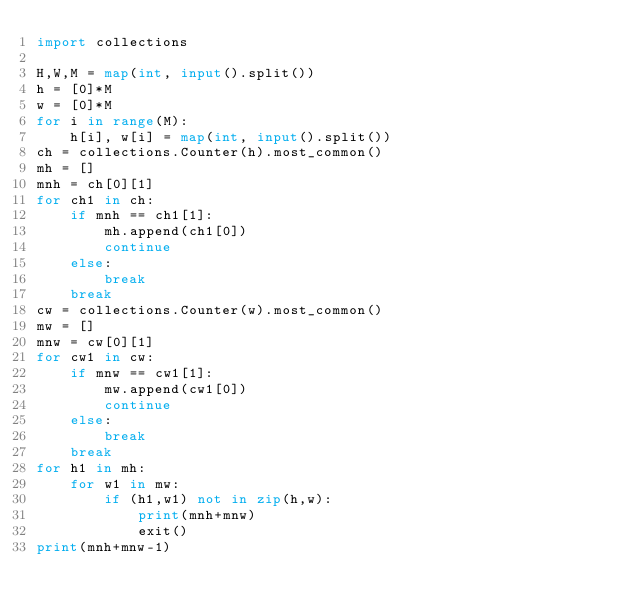Convert code to text. <code><loc_0><loc_0><loc_500><loc_500><_Python_>import collections

H,W,M = map(int, input().split())
h = [0]*M
w = [0]*M
for i in range(M):
    h[i], w[i] = map(int, input().split())
ch = collections.Counter(h).most_common()
mh = []
mnh = ch[0][1]
for ch1 in ch:
    if mnh == ch1[1]:
        mh.append(ch1[0])
        continue
    else:
        break
    break
cw = collections.Counter(w).most_common()
mw = []
mnw = cw[0][1]
for cw1 in cw:
    if mnw == cw1[1]:
        mw.append(cw1[0])
        continue
    else:
        break
    break
for h1 in mh:
    for w1 in mw:
        if (h1,w1) not in zip(h,w):
            print(mnh+mnw)
            exit()
print(mnh+mnw-1)</code> 